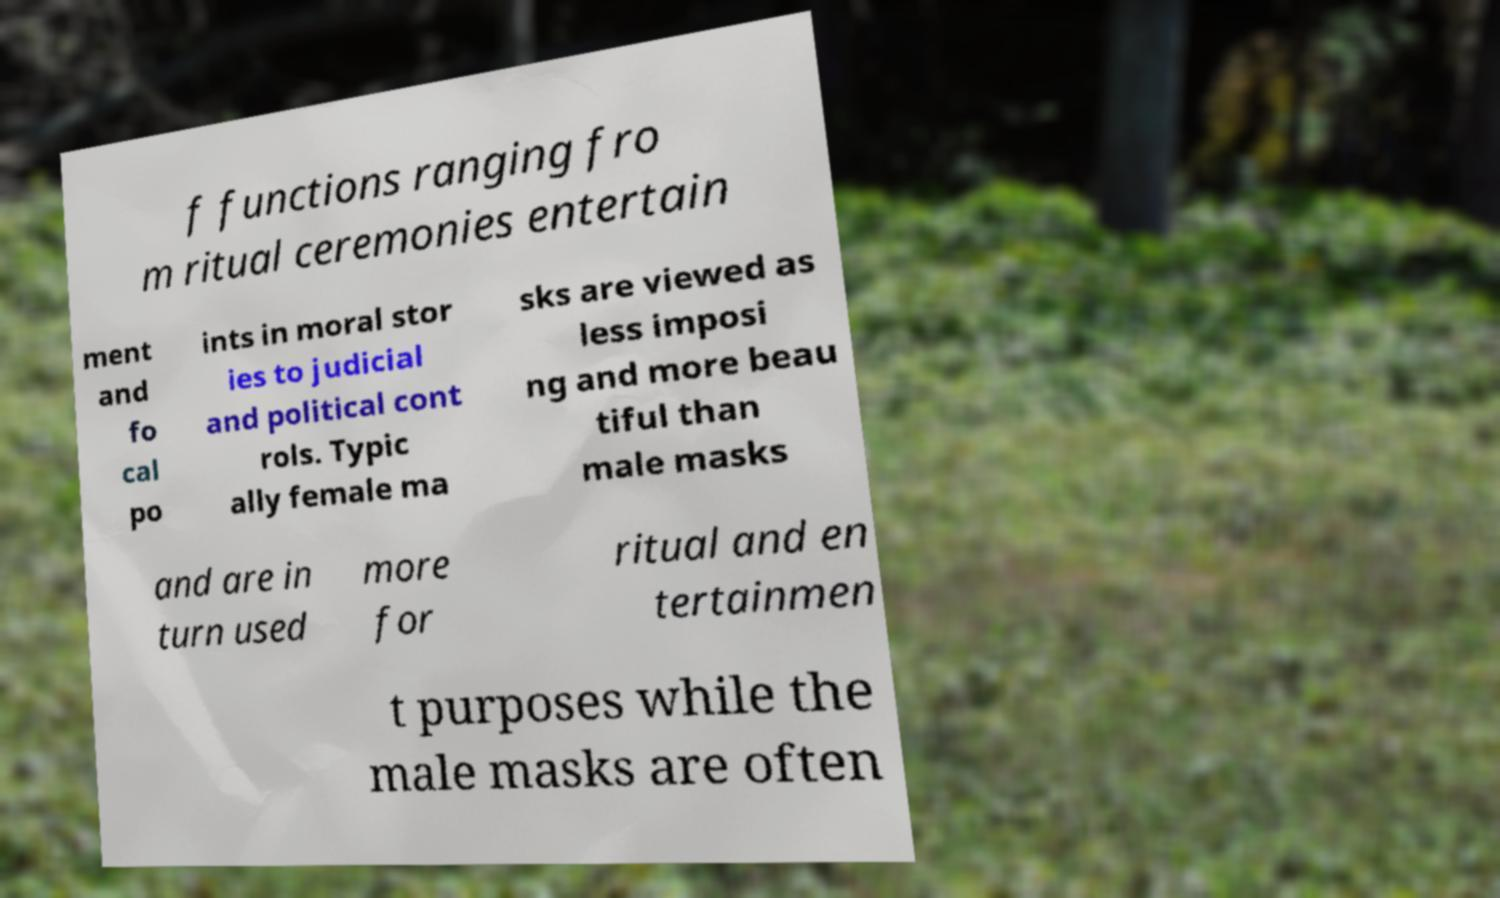Can you accurately transcribe the text from the provided image for me? f functions ranging fro m ritual ceremonies entertain ment and fo cal po ints in moral stor ies to judicial and political cont rols. Typic ally female ma sks are viewed as less imposi ng and more beau tiful than male masks and are in turn used more for ritual and en tertainmen t purposes while the male masks are often 